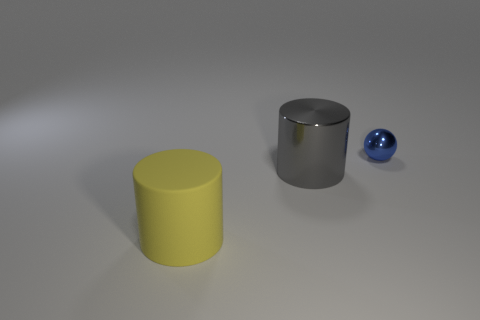What number of small objects are either yellow objects or brown objects?
Ensure brevity in your answer.  0. There is another object that is the same shape as the big gray object; what color is it?
Provide a short and direct response. Yellow. Is the gray metallic cylinder the same size as the rubber thing?
Your answer should be compact. Yes. How many objects are either small yellow rubber cylinders or objects that are to the right of the matte object?
Provide a short and direct response. 2. What is the color of the cylinder that is on the left side of the metallic object on the left side of the small blue metallic thing?
Offer a terse response. Yellow. Does the object to the left of the big shiny thing have the same color as the small object?
Keep it short and to the point. No. What is the large thing right of the big matte thing made of?
Your answer should be very brief. Metal. What is the size of the shiny ball?
Offer a terse response. Small. Are the large cylinder that is behind the yellow rubber cylinder and the blue thing made of the same material?
Offer a very short reply. Yes. How many big matte cubes are there?
Your answer should be very brief. 0. 